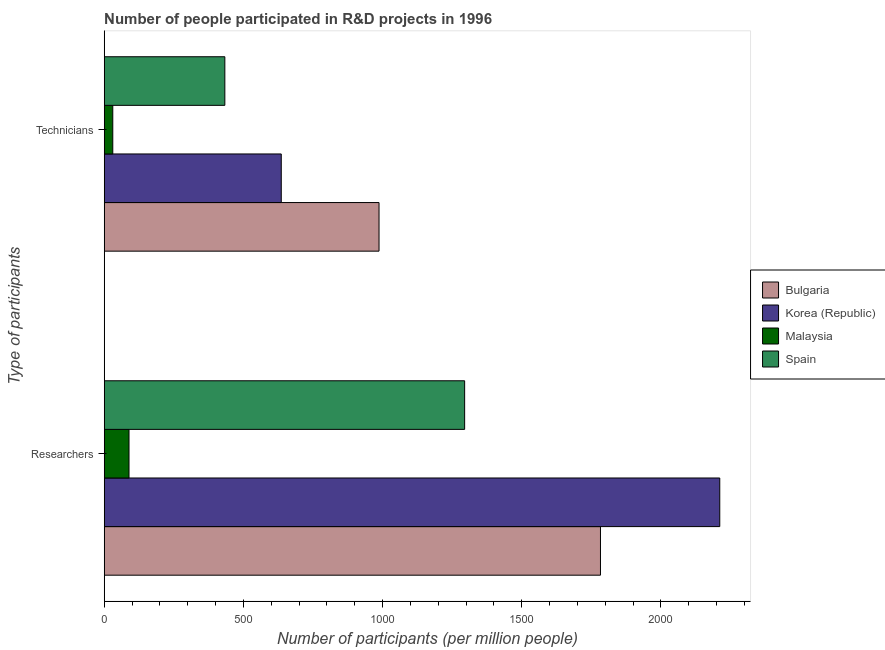Are the number of bars per tick equal to the number of legend labels?
Your answer should be compact. Yes. How many bars are there on the 1st tick from the top?
Offer a terse response. 4. What is the label of the 1st group of bars from the top?
Provide a succinct answer. Technicians. What is the number of researchers in Korea (Republic)?
Provide a succinct answer. 2211.23. Across all countries, what is the maximum number of researchers?
Your response must be concise. 2211.23. Across all countries, what is the minimum number of researchers?
Make the answer very short. 89.08. In which country was the number of researchers minimum?
Make the answer very short. Malaysia. What is the total number of technicians in the graph?
Your response must be concise. 2087.39. What is the difference between the number of researchers in Korea (Republic) and that in Malaysia?
Offer a terse response. 2122.14. What is the difference between the number of technicians in Korea (Republic) and the number of researchers in Spain?
Give a very brief answer. -658.73. What is the average number of researchers per country?
Keep it short and to the point. 1344.43. What is the difference between the number of technicians and number of researchers in Korea (Republic)?
Your answer should be compact. -1575.21. In how many countries, is the number of researchers greater than 1800 ?
Give a very brief answer. 1. What is the ratio of the number of technicians in Bulgaria to that in Spain?
Your answer should be compact. 2.28. Is the number of technicians in Bulgaria less than that in Korea (Republic)?
Provide a short and direct response. No. What does the 4th bar from the top in Technicians represents?
Provide a succinct answer. Bulgaria. What does the 4th bar from the bottom in Technicians represents?
Keep it short and to the point. Spain. What is the difference between two consecutive major ticks on the X-axis?
Offer a terse response. 500. Does the graph contain grids?
Provide a succinct answer. No. How many legend labels are there?
Your answer should be very brief. 4. What is the title of the graph?
Ensure brevity in your answer.  Number of people participated in R&D projects in 1996. What is the label or title of the X-axis?
Your answer should be compact. Number of participants (per million people). What is the label or title of the Y-axis?
Provide a short and direct response. Type of participants. What is the Number of participants (per million people) in Bulgaria in Researchers?
Provide a succinct answer. 1782.67. What is the Number of participants (per million people) in Korea (Republic) in Researchers?
Ensure brevity in your answer.  2211.23. What is the Number of participants (per million people) in Malaysia in Researchers?
Make the answer very short. 89.08. What is the Number of participants (per million people) in Spain in Researchers?
Ensure brevity in your answer.  1294.75. What is the Number of participants (per million people) of Bulgaria in Technicians?
Offer a terse response. 987.23. What is the Number of participants (per million people) of Korea (Republic) in Technicians?
Make the answer very short. 636.02. What is the Number of participants (per million people) of Malaysia in Technicians?
Give a very brief answer. 30.81. What is the Number of participants (per million people) in Spain in Technicians?
Provide a succinct answer. 433.34. Across all Type of participants, what is the maximum Number of participants (per million people) in Bulgaria?
Make the answer very short. 1782.67. Across all Type of participants, what is the maximum Number of participants (per million people) in Korea (Republic)?
Offer a terse response. 2211.23. Across all Type of participants, what is the maximum Number of participants (per million people) in Malaysia?
Give a very brief answer. 89.08. Across all Type of participants, what is the maximum Number of participants (per million people) in Spain?
Make the answer very short. 1294.75. Across all Type of participants, what is the minimum Number of participants (per million people) of Bulgaria?
Ensure brevity in your answer.  987.23. Across all Type of participants, what is the minimum Number of participants (per million people) in Korea (Republic)?
Ensure brevity in your answer.  636.02. Across all Type of participants, what is the minimum Number of participants (per million people) in Malaysia?
Ensure brevity in your answer.  30.81. Across all Type of participants, what is the minimum Number of participants (per million people) in Spain?
Give a very brief answer. 433.34. What is the total Number of participants (per million people) of Bulgaria in the graph?
Give a very brief answer. 2769.9. What is the total Number of participants (per million people) in Korea (Republic) in the graph?
Make the answer very short. 2847.24. What is the total Number of participants (per million people) in Malaysia in the graph?
Give a very brief answer. 119.89. What is the total Number of participants (per million people) in Spain in the graph?
Provide a succinct answer. 1728.08. What is the difference between the Number of participants (per million people) in Bulgaria in Researchers and that in Technicians?
Give a very brief answer. 795.44. What is the difference between the Number of participants (per million people) in Korea (Republic) in Researchers and that in Technicians?
Your answer should be very brief. 1575.21. What is the difference between the Number of participants (per million people) of Malaysia in Researchers and that in Technicians?
Your answer should be very brief. 58.28. What is the difference between the Number of participants (per million people) of Spain in Researchers and that in Technicians?
Your response must be concise. 861.41. What is the difference between the Number of participants (per million people) in Bulgaria in Researchers and the Number of participants (per million people) in Korea (Republic) in Technicians?
Your response must be concise. 1146.65. What is the difference between the Number of participants (per million people) of Bulgaria in Researchers and the Number of participants (per million people) of Malaysia in Technicians?
Your answer should be compact. 1751.86. What is the difference between the Number of participants (per million people) of Bulgaria in Researchers and the Number of participants (per million people) of Spain in Technicians?
Give a very brief answer. 1349.33. What is the difference between the Number of participants (per million people) of Korea (Republic) in Researchers and the Number of participants (per million people) of Malaysia in Technicians?
Keep it short and to the point. 2180.42. What is the difference between the Number of participants (per million people) in Korea (Republic) in Researchers and the Number of participants (per million people) in Spain in Technicians?
Your answer should be very brief. 1777.89. What is the difference between the Number of participants (per million people) of Malaysia in Researchers and the Number of participants (per million people) of Spain in Technicians?
Provide a succinct answer. -344.25. What is the average Number of participants (per million people) in Bulgaria per Type of participants?
Ensure brevity in your answer.  1384.95. What is the average Number of participants (per million people) in Korea (Republic) per Type of participants?
Your answer should be very brief. 1423.62. What is the average Number of participants (per million people) of Malaysia per Type of participants?
Make the answer very short. 59.95. What is the average Number of participants (per million people) in Spain per Type of participants?
Offer a terse response. 864.04. What is the difference between the Number of participants (per million people) of Bulgaria and Number of participants (per million people) of Korea (Republic) in Researchers?
Provide a short and direct response. -428.56. What is the difference between the Number of participants (per million people) of Bulgaria and Number of participants (per million people) of Malaysia in Researchers?
Keep it short and to the point. 1693.59. What is the difference between the Number of participants (per million people) of Bulgaria and Number of participants (per million people) of Spain in Researchers?
Provide a short and direct response. 487.93. What is the difference between the Number of participants (per million people) in Korea (Republic) and Number of participants (per million people) in Malaysia in Researchers?
Provide a short and direct response. 2122.14. What is the difference between the Number of participants (per million people) of Korea (Republic) and Number of participants (per million people) of Spain in Researchers?
Make the answer very short. 916.48. What is the difference between the Number of participants (per million people) in Malaysia and Number of participants (per million people) in Spain in Researchers?
Provide a short and direct response. -1205.66. What is the difference between the Number of participants (per million people) in Bulgaria and Number of participants (per million people) in Korea (Republic) in Technicians?
Provide a succinct answer. 351.21. What is the difference between the Number of participants (per million people) of Bulgaria and Number of participants (per million people) of Malaysia in Technicians?
Make the answer very short. 956.42. What is the difference between the Number of participants (per million people) of Bulgaria and Number of participants (per million people) of Spain in Technicians?
Ensure brevity in your answer.  553.89. What is the difference between the Number of participants (per million people) in Korea (Republic) and Number of participants (per million people) in Malaysia in Technicians?
Provide a short and direct response. 605.21. What is the difference between the Number of participants (per million people) in Korea (Republic) and Number of participants (per million people) in Spain in Technicians?
Make the answer very short. 202.68. What is the difference between the Number of participants (per million people) of Malaysia and Number of participants (per million people) of Spain in Technicians?
Your answer should be very brief. -402.53. What is the ratio of the Number of participants (per million people) of Bulgaria in Researchers to that in Technicians?
Ensure brevity in your answer.  1.81. What is the ratio of the Number of participants (per million people) of Korea (Republic) in Researchers to that in Technicians?
Your answer should be very brief. 3.48. What is the ratio of the Number of participants (per million people) of Malaysia in Researchers to that in Technicians?
Your answer should be very brief. 2.89. What is the ratio of the Number of participants (per million people) in Spain in Researchers to that in Technicians?
Offer a very short reply. 2.99. What is the difference between the highest and the second highest Number of participants (per million people) of Bulgaria?
Your answer should be very brief. 795.44. What is the difference between the highest and the second highest Number of participants (per million people) of Korea (Republic)?
Offer a very short reply. 1575.21. What is the difference between the highest and the second highest Number of participants (per million people) in Malaysia?
Provide a short and direct response. 58.28. What is the difference between the highest and the second highest Number of participants (per million people) in Spain?
Offer a terse response. 861.41. What is the difference between the highest and the lowest Number of participants (per million people) of Bulgaria?
Make the answer very short. 795.44. What is the difference between the highest and the lowest Number of participants (per million people) in Korea (Republic)?
Make the answer very short. 1575.21. What is the difference between the highest and the lowest Number of participants (per million people) in Malaysia?
Your answer should be very brief. 58.28. What is the difference between the highest and the lowest Number of participants (per million people) in Spain?
Keep it short and to the point. 861.41. 